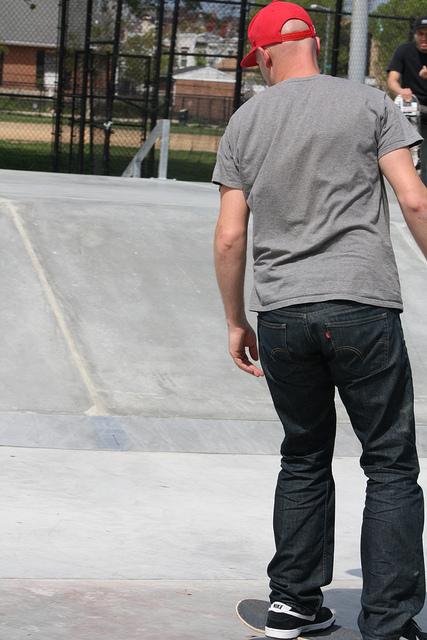Is this guy a cool skater?
Short answer required. No. Is he pushing with his hands?
Quick response, please. No. What is behind the fence?
Short answer required. Park. Is there a truck in the back?
Give a very brief answer. No. Where is the man going?
Answer briefly. Skateboarding. What is the most vibrant color visible?
Answer briefly. Red. What color is the bald man's hair?
Answer briefly. No color. What color is this person's shirt?
Be succinct. Gray. What is the person doing?
Quick response, please. Skateboarding. Is the pavement hot?
Give a very brief answer. No. What is on the ground?
Answer briefly. Skateboard. Is the skateboard on the ground?
Write a very short answer. Yes. Is the skateboarder an adult man or a young boy?
Give a very brief answer. Adult. What color shirt is the man wearing?
Write a very short answer. Gray. What is on the man's head?
Give a very brief answer. Hat. What is the man wearing?
Keep it brief. Jeans. Is this a black and white picture?
Answer briefly. No. Is this picture in color?
Concise answer only. Yes. What kind of league does he play for?
Give a very brief answer. Skateboard. Is this man wearing a hat?
Answer briefly. Yes. What is the individual riding on?
Short answer required. Skateboard. Is this individual approaching an incline or decline?
Keep it brief. Incline. What color is the man's pants?
Answer briefly. Blue. What sport is this figure from?
Give a very brief answer. Skateboarding. What color is the guys hat?
Keep it brief. Red. Is he carrying a briefcase?
Short answer required. No. What is the gender of the individual?
Give a very brief answer. Male. Is he expressing something good happened?
Quick response, please. No. 